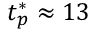<formula> <loc_0><loc_0><loc_500><loc_500>t _ { p } ^ { * } \approx 1 3</formula> 